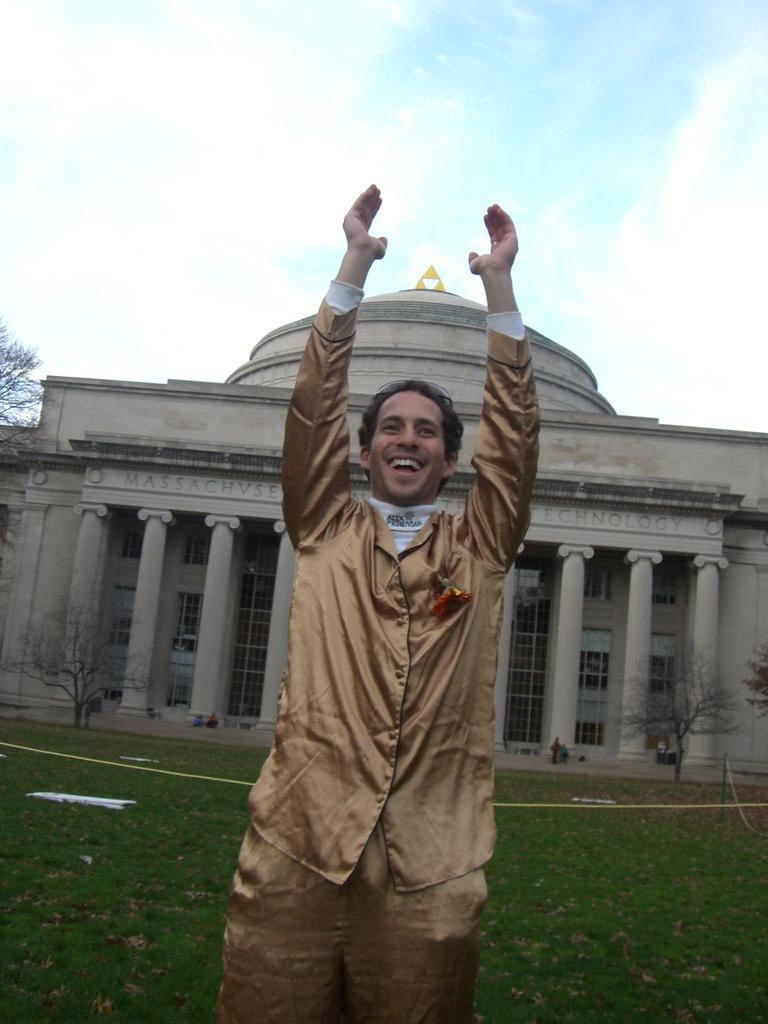Who is present in the image? There is a man in the image. What is the man doing in the image? The man is smiling in the image. What can be seen in the background of the image? There is a building, trees, grass, people, and the sky visible in the background of the image. What is the condition of the sky in the image? The sky is visible in the background of the image, and clouds are present. What type of juice is being served in the image? There is no juice present in the image. What month is it in the image? The image does not provide any information about the month or time of year. 